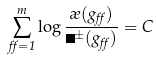<formula> <loc_0><loc_0><loc_500><loc_500>\sum _ { \alpha = 1 } ^ { m } \log \frac { \rho ( g _ { \alpha } ) } { \Upsilon ^ { \pm } ( g _ { \alpha } ) } = C</formula> 